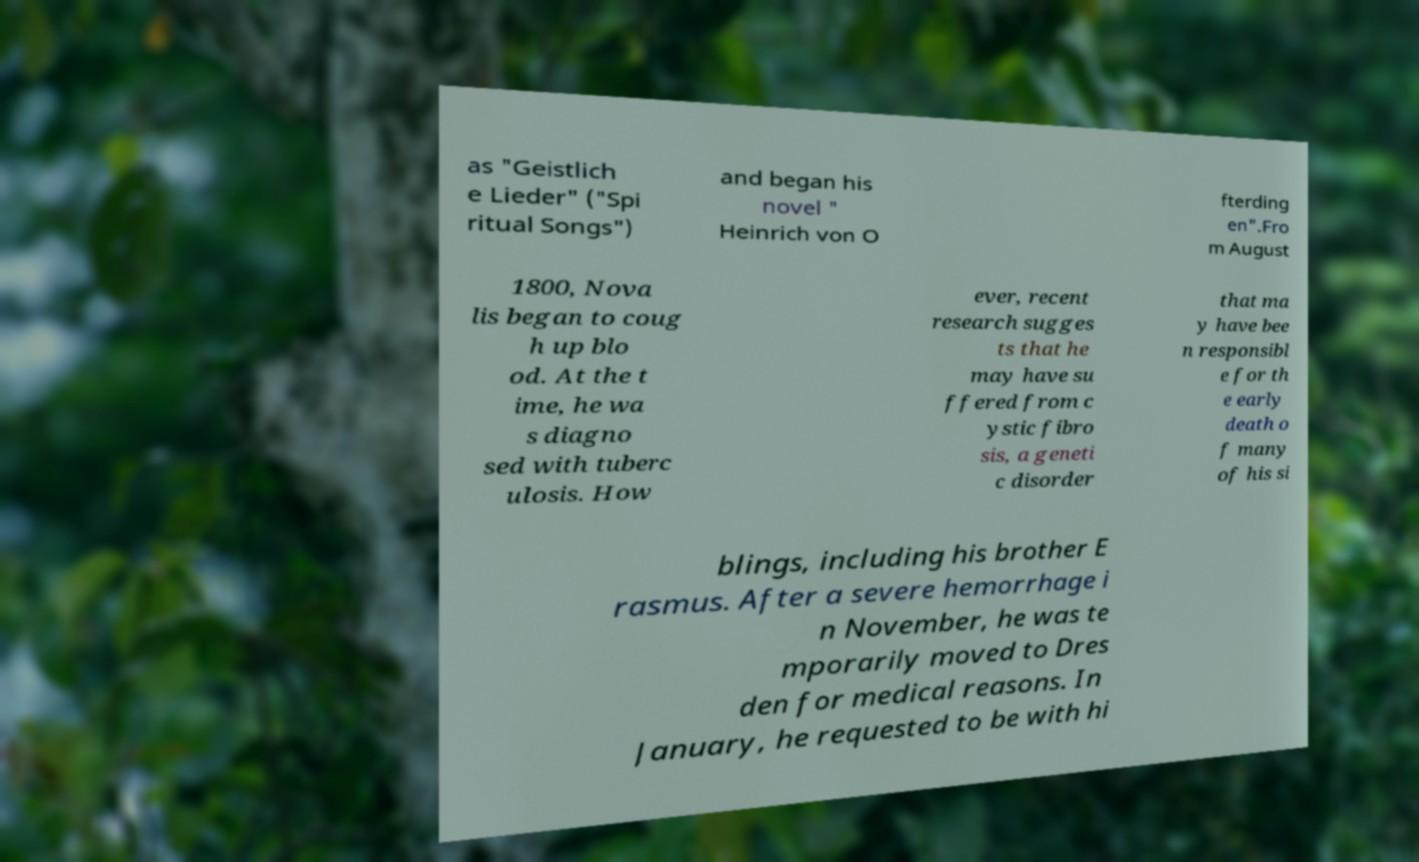Could you extract and type out the text from this image? as "Geistlich e Lieder" ("Spi ritual Songs") and began his novel " Heinrich von O fterding en".Fro m August 1800, Nova lis began to coug h up blo od. At the t ime, he wa s diagno sed with tuberc ulosis. How ever, recent research sugges ts that he may have su ffered from c ystic fibro sis, a geneti c disorder that ma y have bee n responsibl e for th e early death o f many of his si blings, including his brother E rasmus. After a severe hemorrhage i n November, he was te mporarily moved to Dres den for medical reasons. In January, he requested to be with hi 